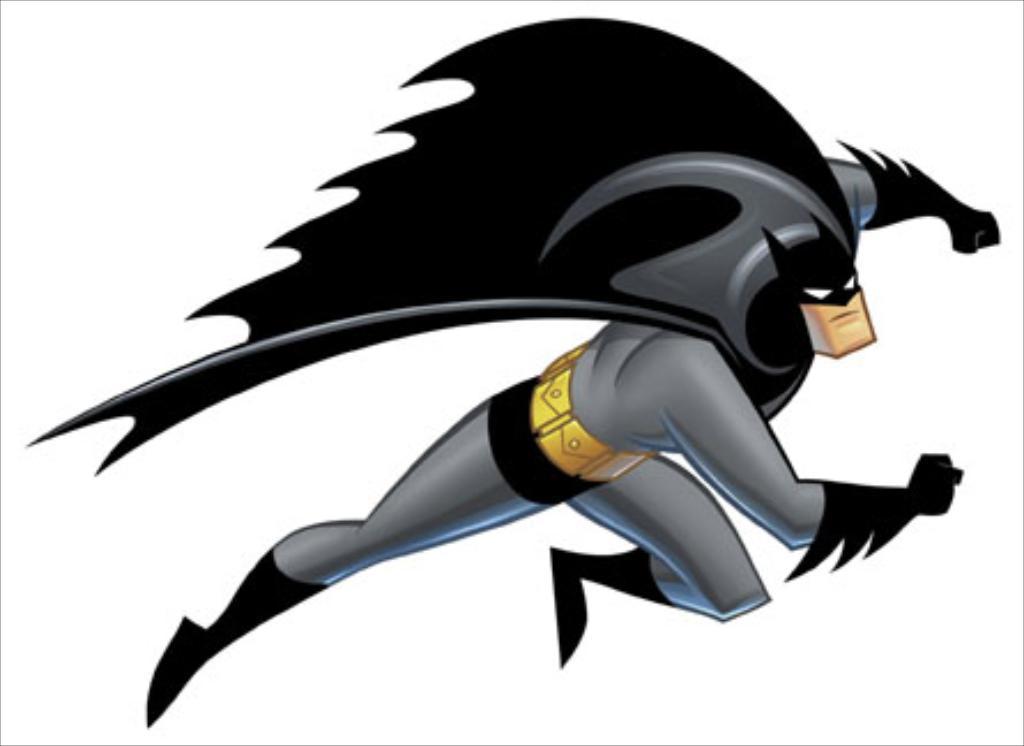Please provide a concise description of this image. In this image I can see the batman with black and ash color dress. He is flying the air. And this is a digital art. 